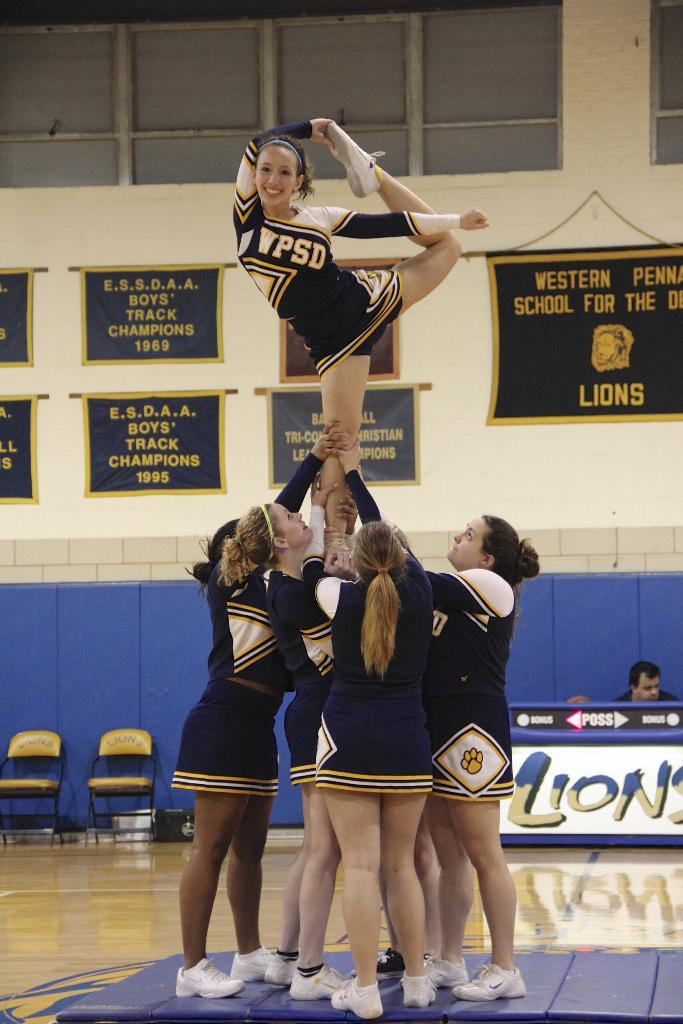<image>
Present a compact description of the photo's key features. A load of cheerleaders with wpds uniforms, one of whom is being lifted 